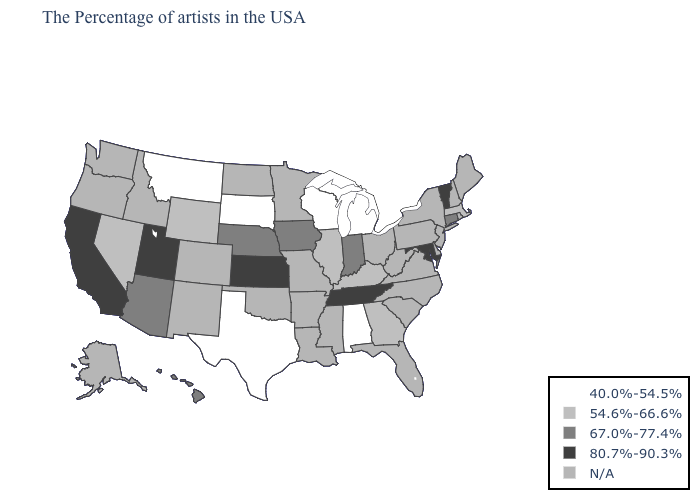Among the states that border Mississippi , which have the lowest value?
Answer briefly. Alabama. What is the highest value in the USA?
Give a very brief answer. 80.7%-90.3%. What is the value of Kansas?
Keep it brief. 80.7%-90.3%. Does the first symbol in the legend represent the smallest category?
Quick response, please. Yes. Name the states that have a value in the range N/A?
Quick response, please. Maine, Rhode Island, New Hampshire, New York, New Jersey, Delaware, Pennsylvania, Virginia, North Carolina, South Carolina, West Virginia, Ohio, Florida, Mississippi, Louisiana, Missouri, Arkansas, Minnesota, Oklahoma, North Dakota, Colorado, New Mexico, Idaho, Washington, Oregon, Alaska. Name the states that have a value in the range N/A?
Write a very short answer. Maine, Rhode Island, New Hampshire, New York, New Jersey, Delaware, Pennsylvania, Virginia, North Carolina, South Carolina, West Virginia, Ohio, Florida, Mississippi, Louisiana, Missouri, Arkansas, Minnesota, Oklahoma, North Dakota, Colorado, New Mexico, Idaho, Washington, Oregon, Alaska. Name the states that have a value in the range 54.6%-66.6%?
Keep it brief. Massachusetts, Georgia, Kentucky, Illinois, Wyoming, Nevada. What is the value of California?
Give a very brief answer. 80.7%-90.3%. Name the states that have a value in the range N/A?
Be succinct. Maine, Rhode Island, New Hampshire, New York, New Jersey, Delaware, Pennsylvania, Virginia, North Carolina, South Carolina, West Virginia, Ohio, Florida, Mississippi, Louisiana, Missouri, Arkansas, Minnesota, Oklahoma, North Dakota, Colorado, New Mexico, Idaho, Washington, Oregon, Alaska. Which states have the lowest value in the West?
Keep it brief. Montana. Name the states that have a value in the range 67.0%-77.4%?
Concise answer only. Connecticut, Indiana, Iowa, Nebraska, Arizona, Hawaii. Does Indiana have the lowest value in the MidWest?
Quick response, please. No. Name the states that have a value in the range N/A?
Give a very brief answer. Maine, Rhode Island, New Hampshire, New York, New Jersey, Delaware, Pennsylvania, Virginia, North Carolina, South Carolina, West Virginia, Ohio, Florida, Mississippi, Louisiana, Missouri, Arkansas, Minnesota, Oklahoma, North Dakota, Colorado, New Mexico, Idaho, Washington, Oregon, Alaska. Does Vermont have the highest value in the Northeast?
Write a very short answer. Yes. 